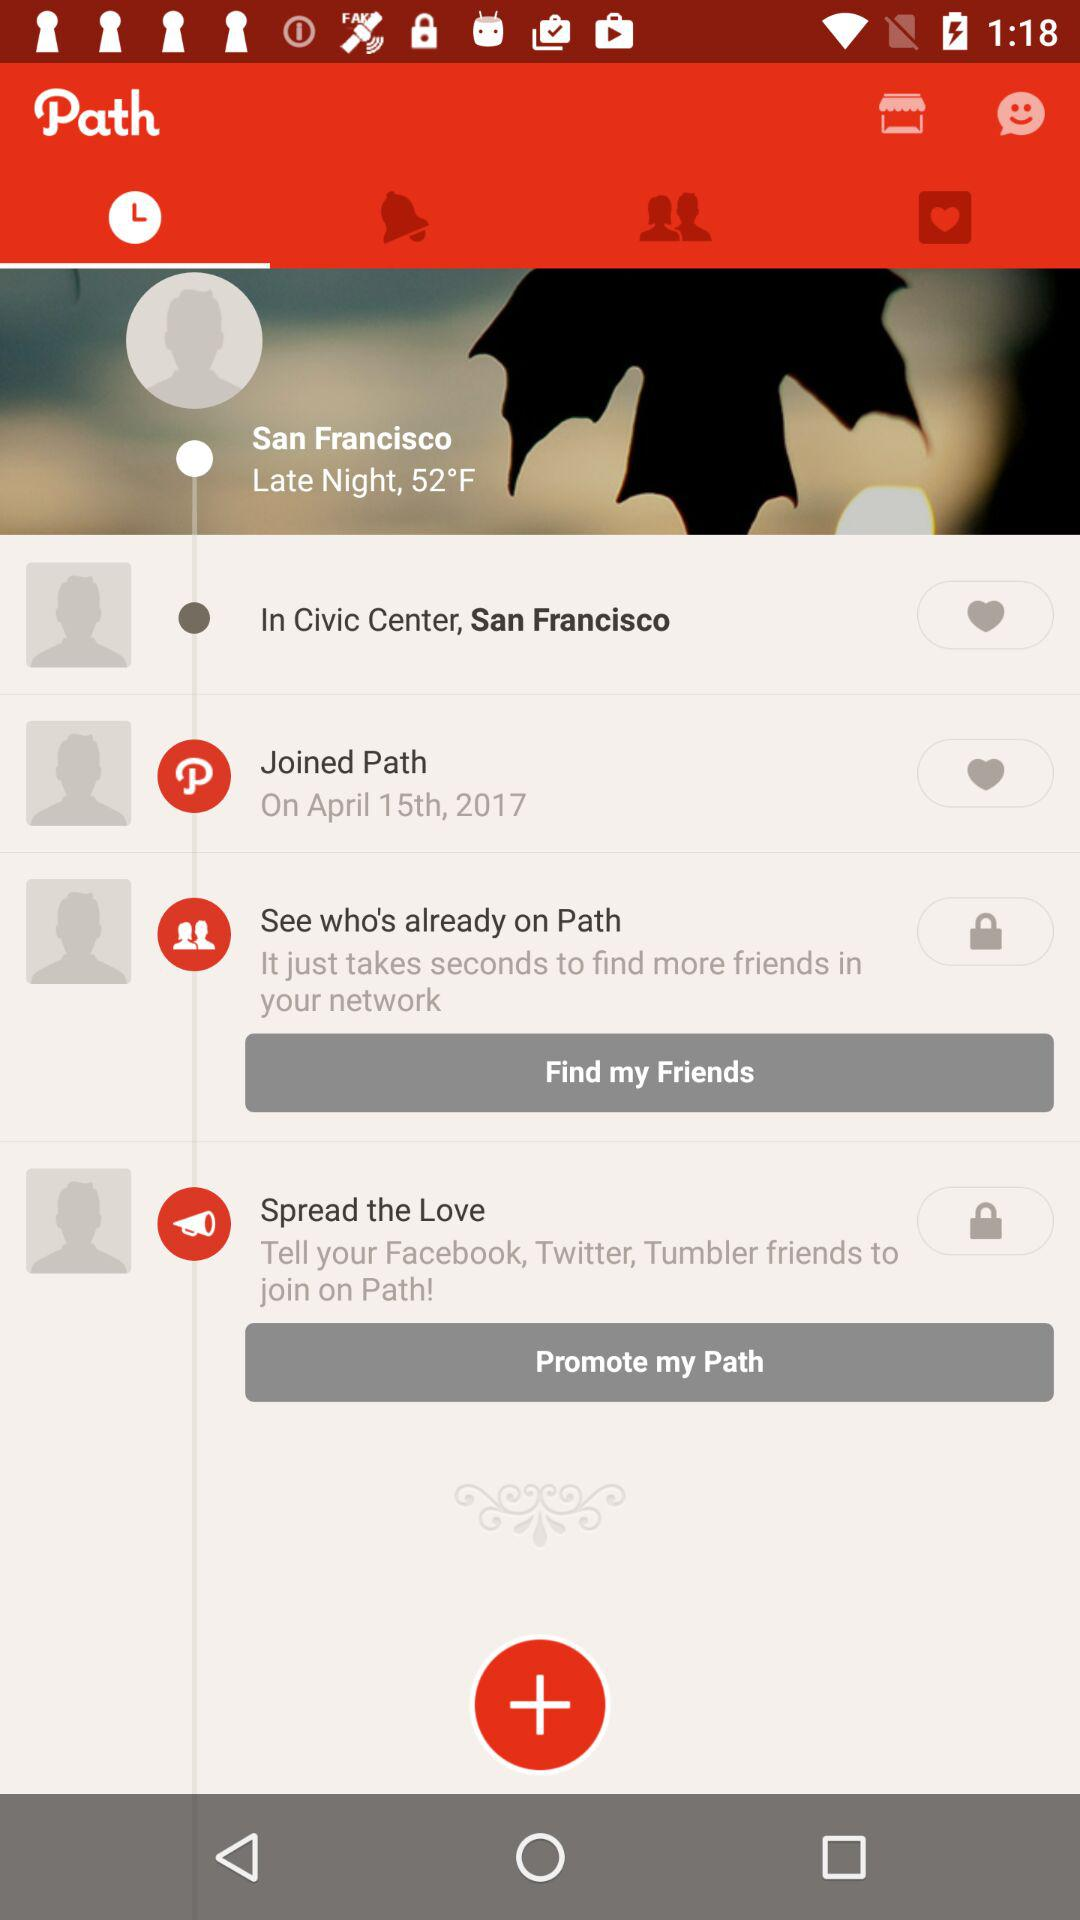What is the name of the application? The name of the application is "Path". 